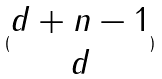Convert formula to latex. <formula><loc_0><loc_0><loc_500><loc_500>( \begin{matrix} d + n - 1 \\ d \end{matrix} )</formula> 